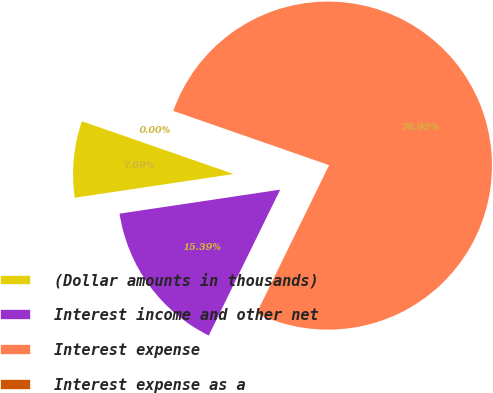Convert chart. <chart><loc_0><loc_0><loc_500><loc_500><pie_chart><fcel>(Dollar amounts in thousands)<fcel>Interest income and other net<fcel>Interest expense<fcel>Interest expense as a<nl><fcel>7.69%<fcel>15.39%<fcel>76.92%<fcel>0.0%<nl></chart> 